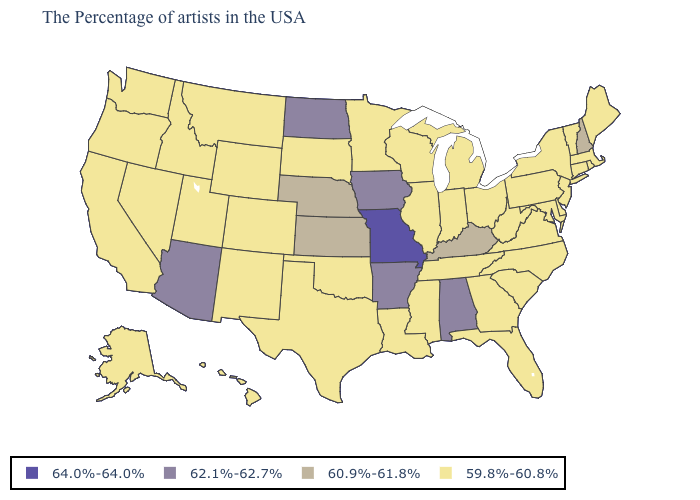What is the lowest value in the South?
Quick response, please. 59.8%-60.8%. Does the first symbol in the legend represent the smallest category?
Concise answer only. No. What is the value of North Carolina?
Quick response, please. 59.8%-60.8%. Name the states that have a value in the range 62.1%-62.7%?
Concise answer only. Alabama, Arkansas, Iowa, North Dakota, Arizona. Name the states that have a value in the range 62.1%-62.7%?
Be succinct. Alabama, Arkansas, Iowa, North Dakota, Arizona. Does New Mexico have a higher value than Maryland?
Concise answer only. No. Name the states that have a value in the range 64.0%-64.0%?
Write a very short answer. Missouri. What is the value of Pennsylvania?
Be succinct. 59.8%-60.8%. What is the value of Oklahoma?
Concise answer only. 59.8%-60.8%. Which states hav the highest value in the South?
Keep it brief. Alabama, Arkansas. Which states have the lowest value in the South?
Be succinct. Delaware, Maryland, Virginia, North Carolina, South Carolina, West Virginia, Florida, Georgia, Tennessee, Mississippi, Louisiana, Oklahoma, Texas. Does Missouri have the highest value in the MidWest?
Give a very brief answer. Yes. What is the value of Hawaii?
Answer briefly. 59.8%-60.8%. What is the value of West Virginia?
Give a very brief answer. 59.8%-60.8%. 